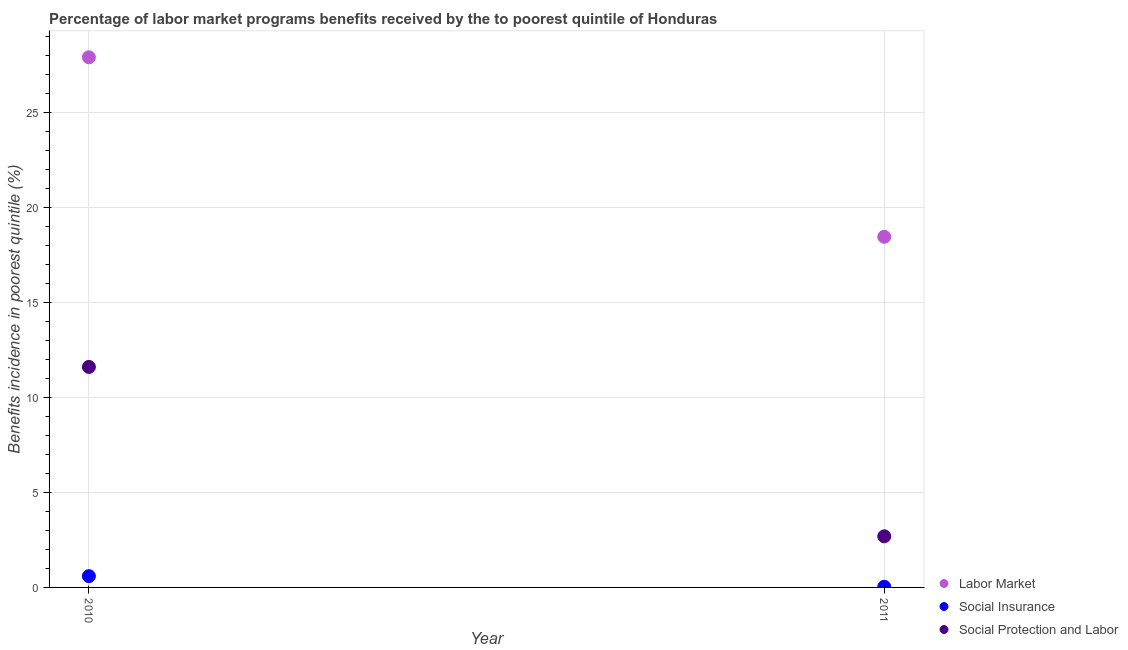How many different coloured dotlines are there?
Your answer should be very brief. 3. What is the percentage of benefits received due to social insurance programs in 2010?
Offer a very short reply. 0.59. Across all years, what is the maximum percentage of benefits received due to social insurance programs?
Offer a very short reply. 0.59. Across all years, what is the minimum percentage of benefits received due to social protection programs?
Give a very brief answer. 2.69. In which year was the percentage of benefits received due to social protection programs maximum?
Offer a terse response. 2010. What is the total percentage of benefits received due to social insurance programs in the graph?
Make the answer very short. 0.63. What is the difference between the percentage of benefits received due to social protection programs in 2010 and that in 2011?
Your answer should be compact. 8.92. What is the difference between the percentage of benefits received due to labor market programs in 2011 and the percentage of benefits received due to social insurance programs in 2010?
Ensure brevity in your answer.  17.88. What is the average percentage of benefits received due to social insurance programs per year?
Your answer should be very brief. 0.31. In the year 2011, what is the difference between the percentage of benefits received due to social protection programs and percentage of benefits received due to social insurance programs?
Offer a terse response. 2.66. In how many years, is the percentage of benefits received due to labor market programs greater than 23 %?
Ensure brevity in your answer.  1. What is the ratio of the percentage of benefits received due to social insurance programs in 2010 to that in 2011?
Keep it short and to the point. 17.11. Is it the case that in every year, the sum of the percentage of benefits received due to labor market programs and percentage of benefits received due to social insurance programs is greater than the percentage of benefits received due to social protection programs?
Make the answer very short. Yes. Is the percentage of benefits received due to social insurance programs strictly greater than the percentage of benefits received due to labor market programs over the years?
Provide a succinct answer. No. How many dotlines are there?
Offer a terse response. 3. What is the difference between two consecutive major ticks on the Y-axis?
Ensure brevity in your answer.  5. How many legend labels are there?
Give a very brief answer. 3. How are the legend labels stacked?
Provide a short and direct response. Vertical. What is the title of the graph?
Your answer should be compact. Percentage of labor market programs benefits received by the to poorest quintile of Honduras. Does "Oil sources" appear as one of the legend labels in the graph?
Give a very brief answer. No. What is the label or title of the Y-axis?
Your answer should be very brief. Benefits incidence in poorest quintile (%). What is the Benefits incidence in poorest quintile (%) of Labor Market in 2010?
Your response must be concise. 27.92. What is the Benefits incidence in poorest quintile (%) of Social Insurance in 2010?
Your response must be concise. 0.59. What is the Benefits incidence in poorest quintile (%) in Social Protection and Labor in 2010?
Offer a very short reply. 11.61. What is the Benefits incidence in poorest quintile (%) in Labor Market in 2011?
Ensure brevity in your answer.  18.47. What is the Benefits incidence in poorest quintile (%) of Social Insurance in 2011?
Give a very brief answer. 0.03. What is the Benefits incidence in poorest quintile (%) in Social Protection and Labor in 2011?
Your answer should be compact. 2.69. Across all years, what is the maximum Benefits incidence in poorest quintile (%) of Labor Market?
Ensure brevity in your answer.  27.92. Across all years, what is the maximum Benefits incidence in poorest quintile (%) of Social Insurance?
Offer a very short reply. 0.59. Across all years, what is the maximum Benefits incidence in poorest quintile (%) of Social Protection and Labor?
Offer a very short reply. 11.61. Across all years, what is the minimum Benefits incidence in poorest quintile (%) of Labor Market?
Give a very brief answer. 18.47. Across all years, what is the minimum Benefits incidence in poorest quintile (%) of Social Insurance?
Your answer should be very brief. 0.03. Across all years, what is the minimum Benefits incidence in poorest quintile (%) in Social Protection and Labor?
Ensure brevity in your answer.  2.69. What is the total Benefits incidence in poorest quintile (%) in Labor Market in the graph?
Your answer should be very brief. 46.39. What is the total Benefits incidence in poorest quintile (%) of Social Insurance in the graph?
Ensure brevity in your answer.  0.63. What is the total Benefits incidence in poorest quintile (%) of Social Protection and Labor in the graph?
Give a very brief answer. 14.31. What is the difference between the Benefits incidence in poorest quintile (%) in Labor Market in 2010 and that in 2011?
Give a very brief answer. 9.45. What is the difference between the Benefits incidence in poorest quintile (%) in Social Insurance in 2010 and that in 2011?
Your answer should be compact. 0.56. What is the difference between the Benefits incidence in poorest quintile (%) of Social Protection and Labor in 2010 and that in 2011?
Offer a very short reply. 8.92. What is the difference between the Benefits incidence in poorest quintile (%) in Labor Market in 2010 and the Benefits incidence in poorest quintile (%) in Social Insurance in 2011?
Your answer should be compact. 27.89. What is the difference between the Benefits incidence in poorest quintile (%) of Labor Market in 2010 and the Benefits incidence in poorest quintile (%) of Social Protection and Labor in 2011?
Make the answer very short. 25.23. What is the difference between the Benefits incidence in poorest quintile (%) of Social Insurance in 2010 and the Benefits incidence in poorest quintile (%) of Social Protection and Labor in 2011?
Your response must be concise. -2.1. What is the average Benefits incidence in poorest quintile (%) of Labor Market per year?
Ensure brevity in your answer.  23.2. What is the average Benefits incidence in poorest quintile (%) in Social Insurance per year?
Your answer should be compact. 0.31. What is the average Benefits incidence in poorest quintile (%) of Social Protection and Labor per year?
Your response must be concise. 7.15. In the year 2010, what is the difference between the Benefits incidence in poorest quintile (%) in Labor Market and Benefits incidence in poorest quintile (%) in Social Insurance?
Provide a succinct answer. 27.33. In the year 2010, what is the difference between the Benefits incidence in poorest quintile (%) in Labor Market and Benefits incidence in poorest quintile (%) in Social Protection and Labor?
Your answer should be very brief. 16.31. In the year 2010, what is the difference between the Benefits incidence in poorest quintile (%) in Social Insurance and Benefits incidence in poorest quintile (%) in Social Protection and Labor?
Your answer should be compact. -11.02. In the year 2011, what is the difference between the Benefits incidence in poorest quintile (%) in Labor Market and Benefits incidence in poorest quintile (%) in Social Insurance?
Your response must be concise. 18.44. In the year 2011, what is the difference between the Benefits incidence in poorest quintile (%) in Labor Market and Benefits incidence in poorest quintile (%) in Social Protection and Labor?
Your answer should be very brief. 15.78. In the year 2011, what is the difference between the Benefits incidence in poorest quintile (%) in Social Insurance and Benefits incidence in poorest quintile (%) in Social Protection and Labor?
Give a very brief answer. -2.66. What is the ratio of the Benefits incidence in poorest quintile (%) in Labor Market in 2010 to that in 2011?
Provide a succinct answer. 1.51. What is the ratio of the Benefits incidence in poorest quintile (%) in Social Insurance in 2010 to that in 2011?
Offer a terse response. 17.11. What is the ratio of the Benefits incidence in poorest quintile (%) of Social Protection and Labor in 2010 to that in 2011?
Keep it short and to the point. 4.31. What is the difference between the highest and the second highest Benefits incidence in poorest quintile (%) in Labor Market?
Your response must be concise. 9.45. What is the difference between the highest and the second highest Benefits incidence in poorest quintile (%) of Social Insurance?
Ensure brevity in your answer.  0.56. What is the difference between the highest and the second highest Benefits incidence in poorest quintile (%) of Social Protection and Labor?
Your response must be concise. 8.92. What is the difference between the highest and the lowest Benefits incidence in poorest quintile (%) in Labor Market?
Provide a succinct answer. 9.45. What is the difference between the highest and the lowest Benefits incidence in poorest quintile (%) of Social Insurance?
Your answer should be very brief. 0.56. What is the difference between the highest and the lowest Benefits incidence in poorest quintile (%) in Social Protection and Labor?
Make the answer very short. 8.92. 